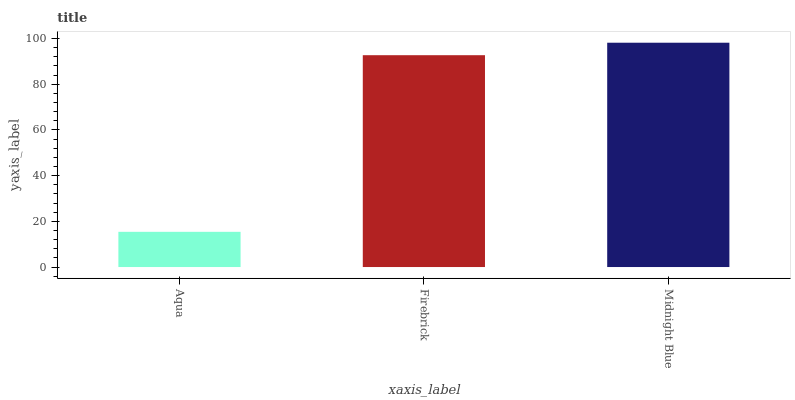Is Aqua the minimum?
Answer yes or no. Yes. Is Midnight Blue the maximum?
Answer yes or no. Yes. Is Firebrick the minimum?
Answer yes or no. No. Is Firebrick the maximum?
Answer yes or no. No. Is Firebrick greater than Aqua?
Answer yes or no. Yes. Is Aqua less than Firebrick?
Answer yes or no. Yes. Is Aqua greater than Firebrick?
Answer yes or no. No. Is Firebrick less than Aqua?
Answer yes or no. No. Is Firebrick the high median?
Answer yes or no. Yes. Is Firebrick the low median?
Answer yes or no. Yes. Is Aqua the high median?
Answer yes or no. No. Is Aqua the low median?
Answer yes or no. No. 